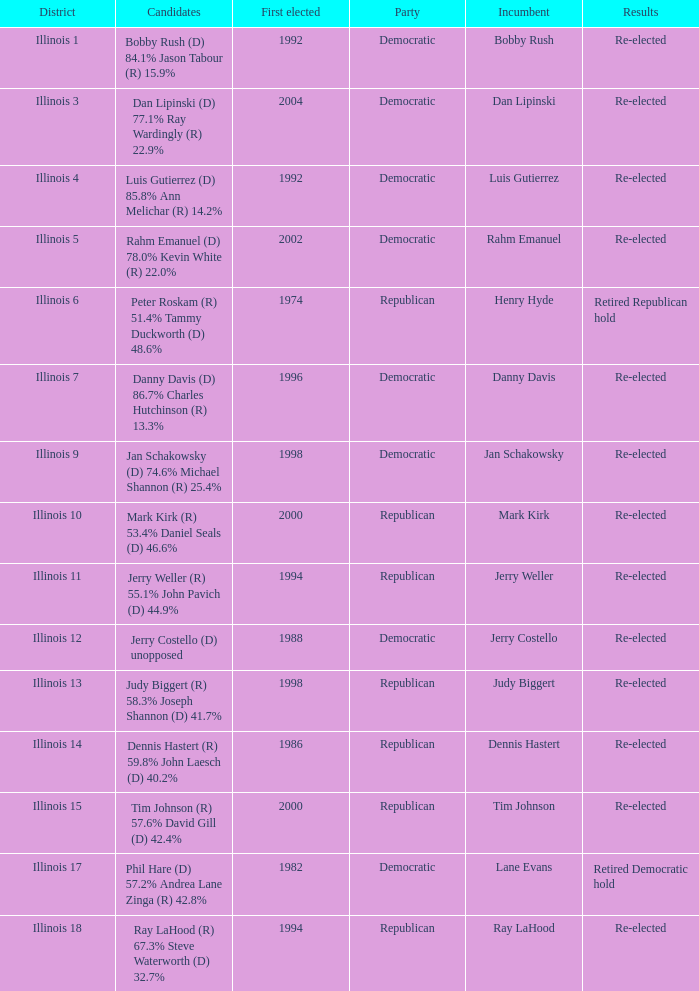What is the district when the first elected was in 1986? Illinois 14. 